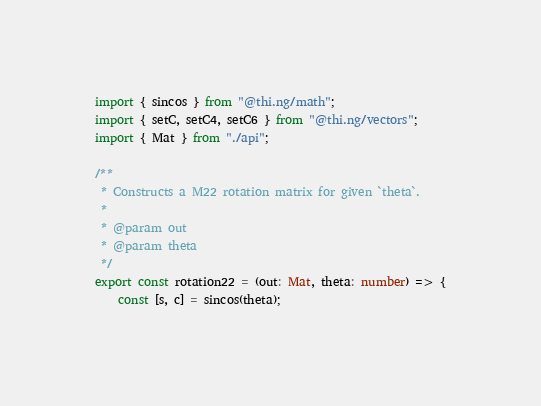<code> <loc_0><loc_0><loc_500><loc_500><_TypeScript_>import { sincos } from "@thi.ng/math";
import { setC, setC4, setC6 } from "@thi.ng/vectors";
import { Mat } from "./api";

/**
 * Constructs a M22 rotation matrix for given `theta`.
 *
 * @param out
 * @param theta
 */
export const rotation22 = (out: Mat, theta: number) => {
    const [s, c] = sincos(theta);</code> 